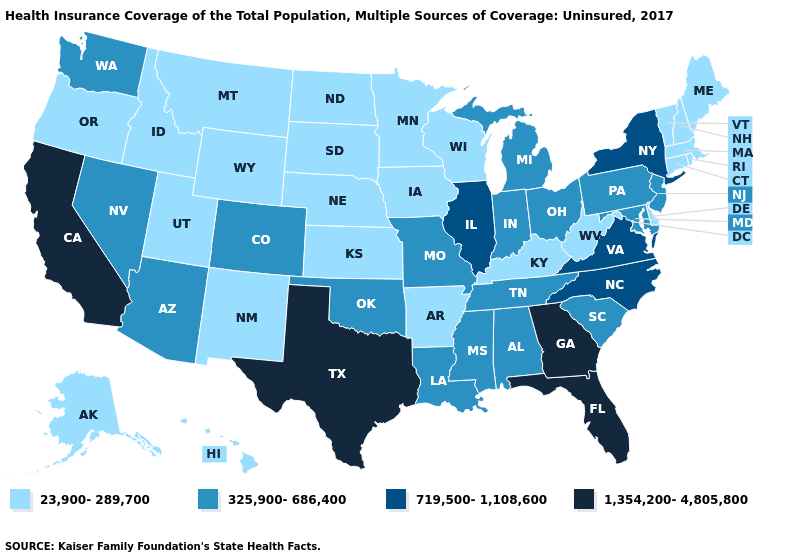Among the states that border West Virginia , does Maryland have the lowest value?
Write a very short answer. No. Which states have the highest value in the USA?
Quick response, please. California, Florida, Georgia, Texas. What is the value of North Dakota?
Be succinct. 23,900-289,700. What is the highest value in states that border New Mexico?
Be succinct. 1,354,200-4,805,800. Name the states that have a value in the range 719,500-1,108,600?
Write a very short answer. Illinois, New York, North Carolina, Virginia. What is the value of New Hampshire?
Concise answer only. 23,900-289,700. Does Colorado have a higher value than New Hampshire?
Concise answer only. Yes. What is the value of Hawaii?
Concise answer only. 23,900-289,700. What is the highest value in the MidWest ?
Answer briefly. 719,500-1,108,600. Which states hav the highest value in the Northeast?
Concise answer only. New York. Name the states that have a value in the range 325,900-686,400?
Quick response, please. Alabama, Arizona, Colorado, Indiana, Louisiana, Maryland, Michigan, Mississippi, Missouri, Nevada, New Jersey, Ohio, Oklahoma, Pennsylvania, South Carolina, Tennessee, Washington. Name the states that have a value in the range 719,500-1,108,600?
Quick response, please. Illinois, New York, North Carolina, Virginia. Name the states that have a value in the range 325,900-686,400?
Be succinct. Alabama, Arizona, Colorado, Indiana, Louisiana, Maryland, Michigan, Mississippi, Missouri, Nevada, New Jersey, Ohio, Oklahoma, Pennsylvania, South Carolina, Tennessee, Washington. What is the value of Montana?
Give a very brief answer. 23,900-289,700. Name the states that have a value in the range 719,500-1,108,600?
Quick response, please. Illinois, New York, North Carolina, Virginia. 